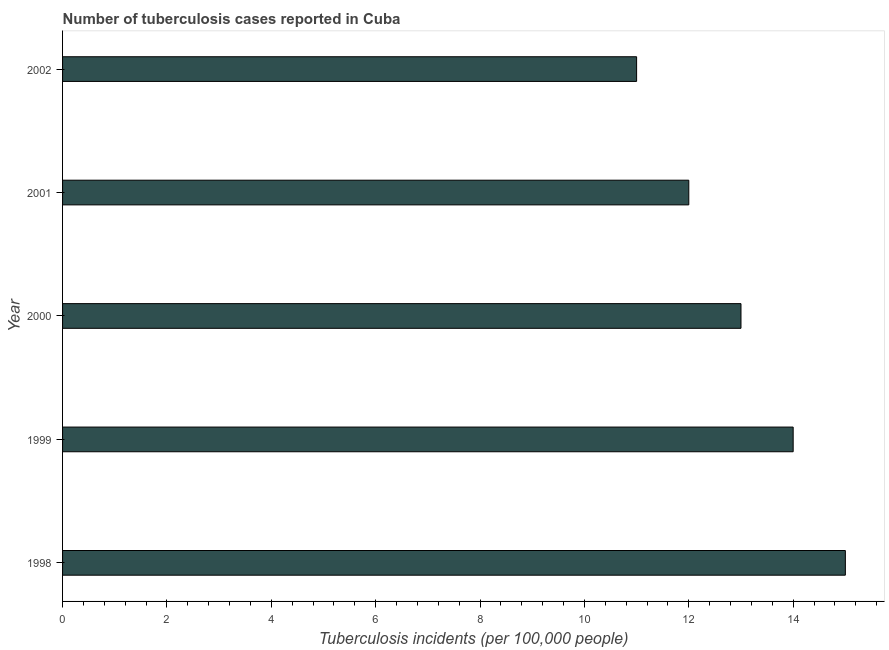Does the graph contain grids?
Your answer should be very brief. No. What is the title of the graph?
Make the answer very short. Number of tuberculosis cases reported in Cuba. What is the label or title of the X-axis?
Keep it short and to the point. Tuberculosis incidents (per 100,0 people). What is the label or title of the Y-axis?
Your answer should be compact. Year. What is the number of tuberculosis incidents in 2000?
Ensure brevity in your answer.  13. Across all years, what is the maximum number of tuberculosis incidents?
Your answer should be compact. 15. What is the median number of tuberculosis incidents?
Your response must be concise. 13. In how many years, is the number of tuberculosis incidents greater than 7.6 ?
Make the answer very short. 5. What is the ratio of the number of tuberculosis incidents in 1998 to that in 2002?
Keep it short and to the point. 1.36. Is the sum of the number of tuberculosis incidents in 1999 and 2001 greater than the maximum number of tuberculosis incidents across all years?
Give a very brief answer. Yes. In how many years, is the number of tuberculosis incidents greater than the average number of tuberculosis incidents taken over all years?
Ensure brevity in your answer.  2. How many bars are there?
Your response must be concise. 5. Are all the bars in the graph horizontal?
Offer a very short reply. Yes. How many years are there in the graph?
Offer a very short reply. 5. What is the difference between two consecutive major ticks on the X-axis?
Make the answer very short. 2. Are the values on the major ticks of X-axis written in scientific E-notation?
Ensure brevity in your answer.  No. What is the Tuberculosis incidents (per 100,000 people) of 1999?
Your answer should be compact. 14. What is the Tuberculosis incidents (per 100,000 people) in 2000?
Offer a very short reply. 13. What is the difference between the Tuberculosis incidents (per 100,000 people) in 1998 and 1999?
Your answer should be compact. 1. What is the difference between the Tuberculosis incidents (per 100,000 people) in 1998 and 2000?
Make the answer very short. 2. What is the difference between the Tuberculosis incidents (per 100,000 people) in 1998 and 2001?
Your answer should be very brief. 3. What is the difference between the Tuberculosis incidents (per 100,000 people) in 1998 and 2002?
Ensure brevity in your answer.  4. What is the difference between the Tuberculosis incidents (per 100,000 people) in 1999 and 2002?
Your answer should be very brief. 3. What is the difference between the Tuberculosis incidents (per 100,000 people) in 2000 and 2002?
Ensure brevity in your answer.  2. What is the difference between the Tuberculosis incidents (per 100,000 people) in 2001 and 2002?
Your answer should be compact. 1. What is the ratio of the Tuberculosis incidents (per 100,000 people) in 1998 to that in 1999?
Make the answer very short. 1.07. What is the ratio of the Tuberculosis incidents (per 100,000 people) in 1998 to that in 2000?
Your answer should be very brief. 1.15. What is the ratio of the Tuberculosis incidents (per 100,000 people) in 1998 to that in 2001?
Ensure brevity in your answer.  1.25. What is the ratio of the Tuberculosis incidents (per 100,000 people) in 1998 to that in 2002?
Give a very brief answer. 1.36. What is the ratio of the Tuberculosis incidents (per 100,000 people) in 1999 to that in 2000?
Offer a very short reply. 1.08. What is the ratio of the Tuberculosis incidents (per 100,000 people) in 1999 to that in 2001?
Provide a succinct answer. 1.17. What is the ratio of the Tuberculosis incidents (per 100,000 people) in 1999 to that in 2002?
Give a very brief answer. 1.27. What is the ratio of the Tuberculosis incidents (per 100,000 people) in 2000 to that in 2001?
Keep it short and to the point. 1.08. What is the ratio of the Tuberculosis incidents (per 100,000 people) in 2000 to that in 2002?
Give a very brief answer. 1.18. What is the ratio of the Tuberculosis incidents (per 100,000 people) in 2001 to that in 2002?
Your answer should be compact. 1.09. 